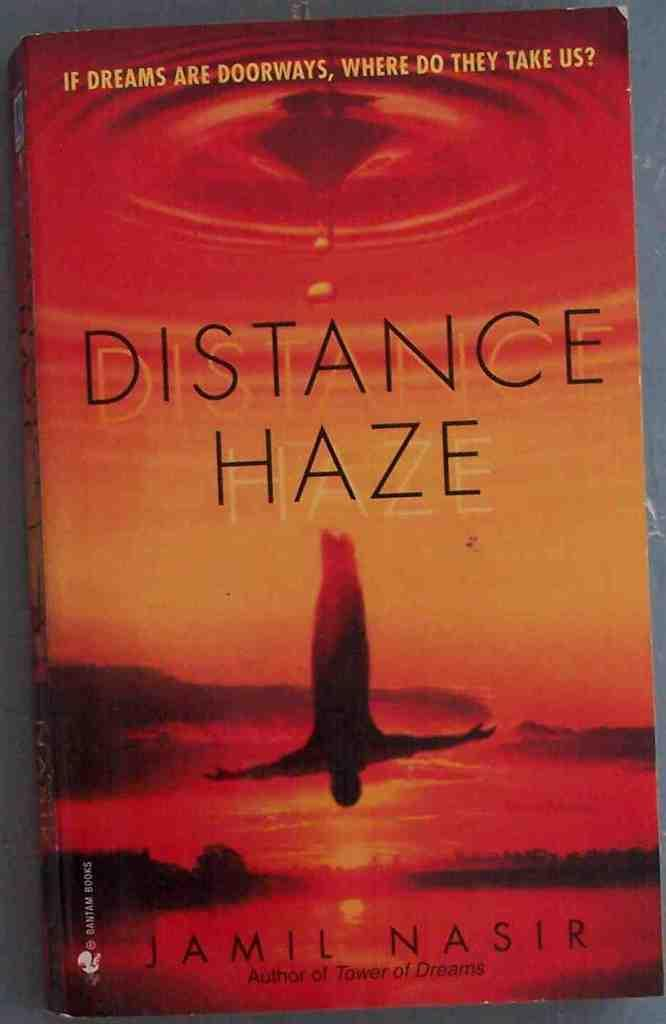<image>
Share a concise interpretation of the image provided. A book called Distance Haze shows someone diving or falling on the cover. 